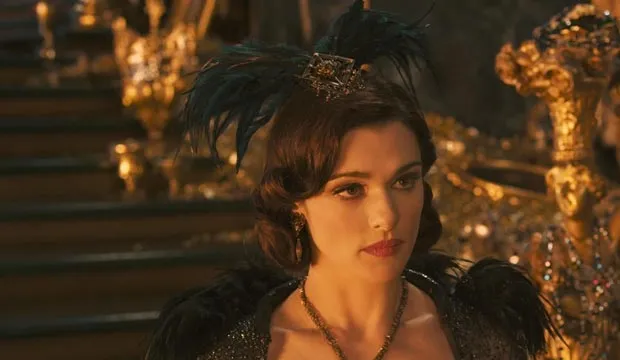Let's imagine a fantastical scenario: What if the throne behind the woman was magical? What would it do? In a fantastical twist, the throne behind the woman is revealed to be an ancient magical artifact known as the Throne of Echoing Destinies. It has the power to amplify the intentions and emotions of the person seated upon it, allowing them to project their thoughts and commands across vast distances. When Evanora sits on the throne, ripples of golden light emanate from the seat, weaving through the air like tendrils of power. These waves can influence both allies and enemies, inspiring loyalty or fear, and even altering the course of fate. However, the throne demands a price—each use drains a measure of the user’s life force, reminding Evanora that with great power comes great sacrifice. Its magic is a double-edged sword, a powerful boon in times of need but also a constant test of the wielder's resolve and wisdom. 